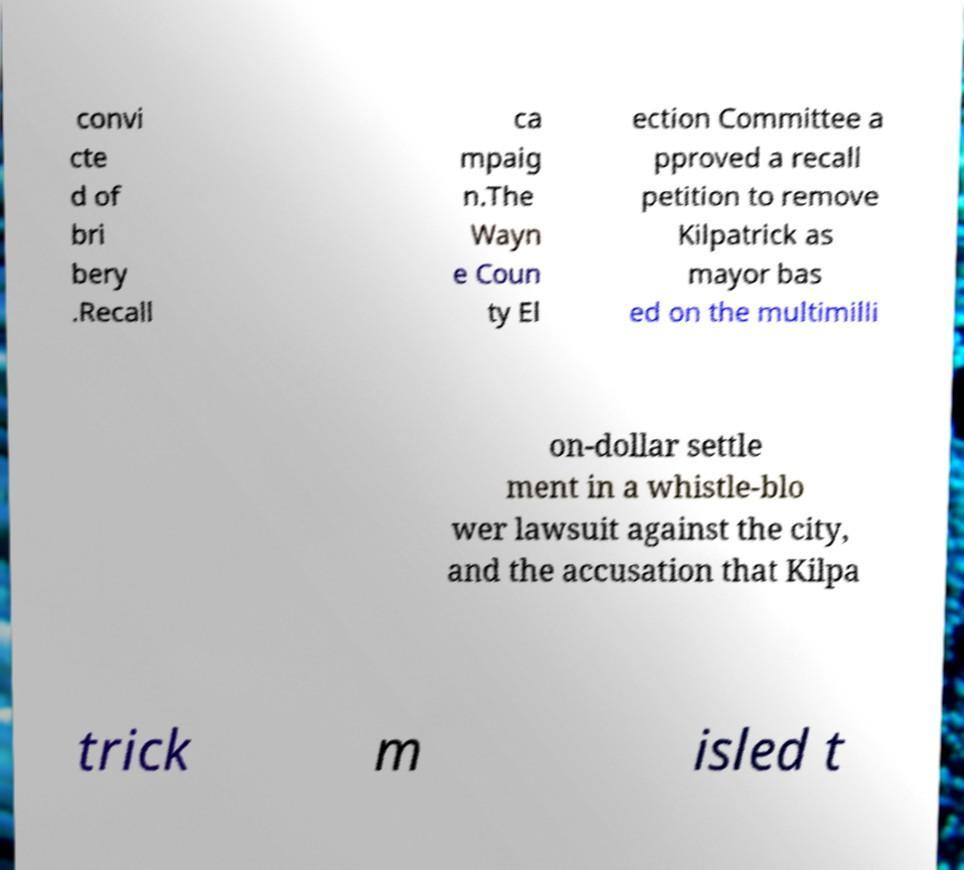I need the written content from this picture converted into text. Can you do that? convi cte d of bri bery .Recall ca mpaig n.The Wayn e Coun ty El ection Committee a pproved a recall petition to remove Kilpatrick as mayor bas ed on the multimilli on-dollar settle ment in a whistle-blo wer lawsuit against the city, and the accusation that Kilpa trick m isled t 